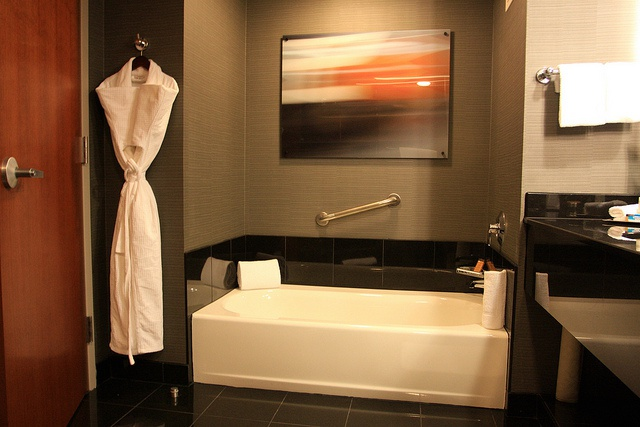Describe the objects in this image and their specific colors. I can see sink in maroon, black, and tan tones and bottle in maroon, black, and brown tones in this image. 